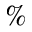<formula> <loc_0><loc_0><loc_500><loc_500>\%</formula> 